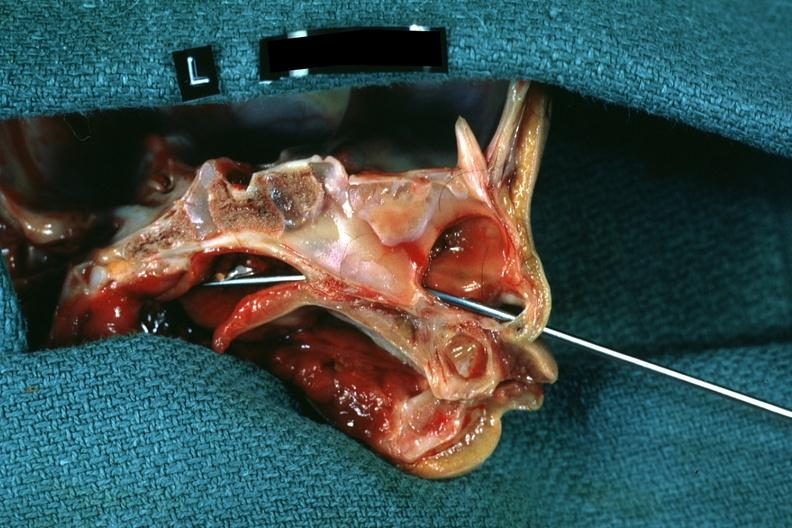what was side showing patency right side?
Answer the question using a single word or phrase. Not patent 